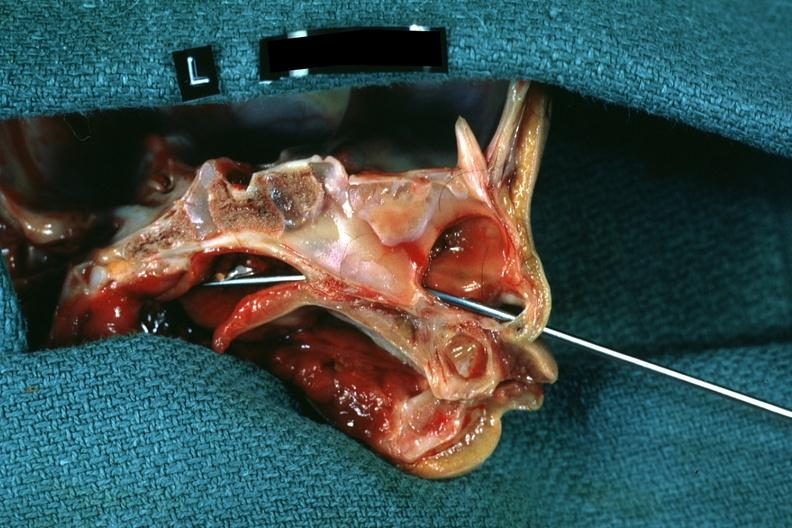what was side showing patency right side?
Answer the question using a single word or phrase. Not patent 